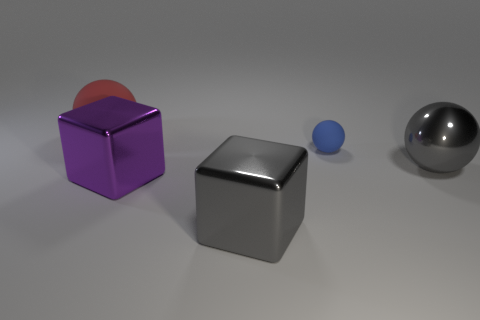Are there more big gray shiny objects that are on the left side of the purple shiny thing than metal objects that are to the right of the gray ball? Upon examination, the left side of the purple object has one large, shiny gray object. To the right of the gray ball, there are no metal objects visible, meaning there are indeed more large gray shiny objects on the left side of the purple object than metal ones to the right of the gray ball. 